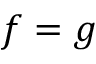<formula> <loc_0><loc_0><loc_500><loc_500>f = g</formula> 